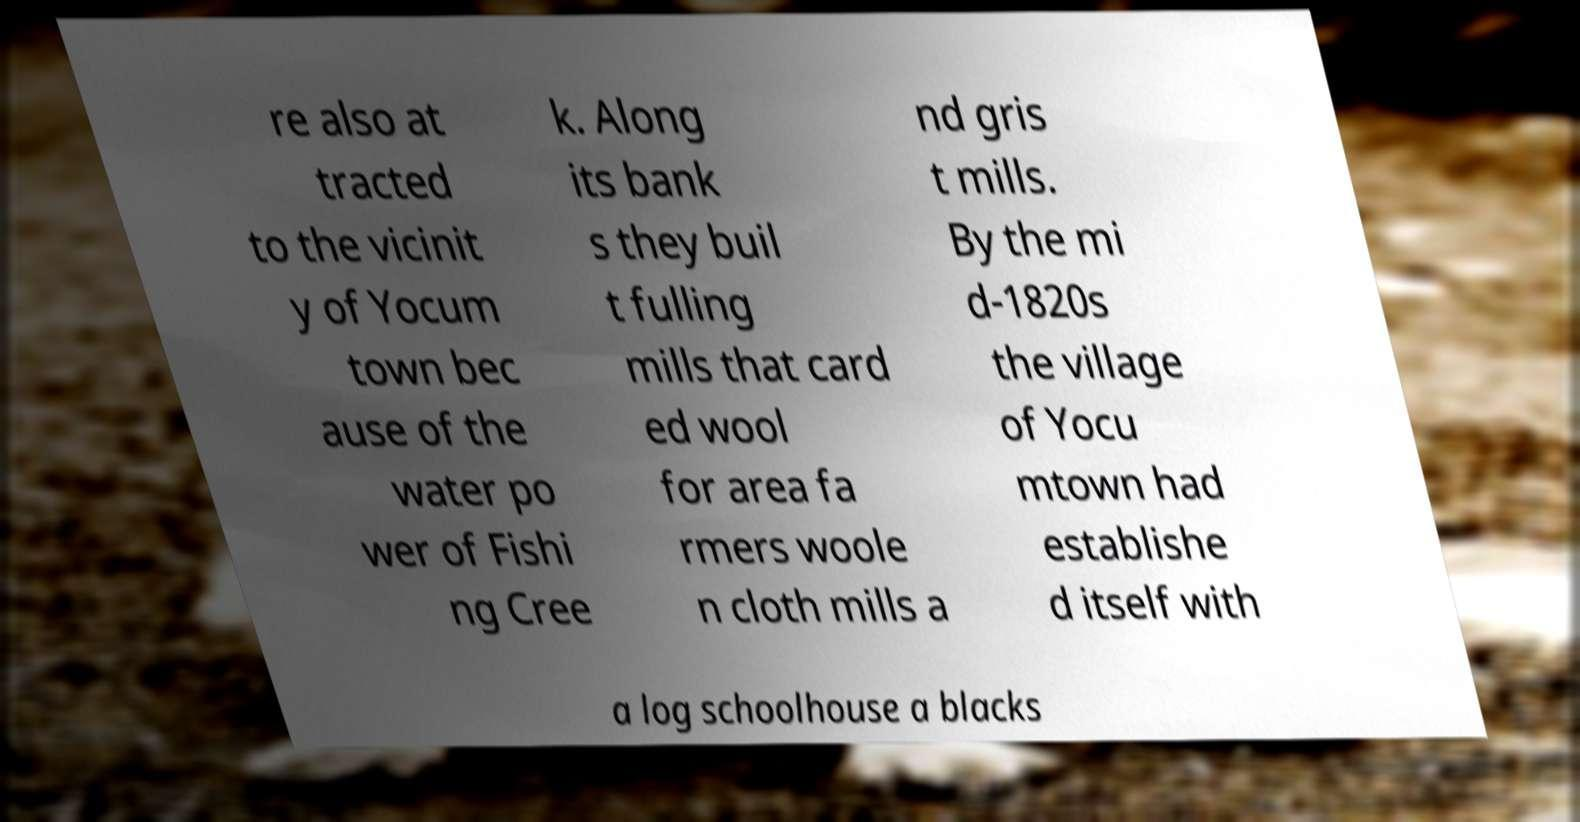Please read and relay the text visible in this image. What does it say? re also at tracted to the vicinit y of Yocum town bec ause of the water po wer of Fishi ng Cree k. Along its bank s they buil t fulling mills that card ed wool for area fa rmers woole n cloth mills a nd gris t mills. By the mi d-1820s the village of Yocu mtown had establishe d itself with a log schoolhouse a blacks 